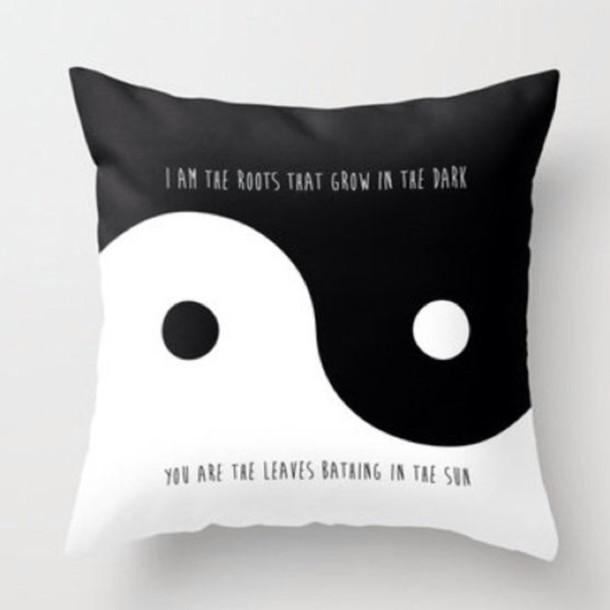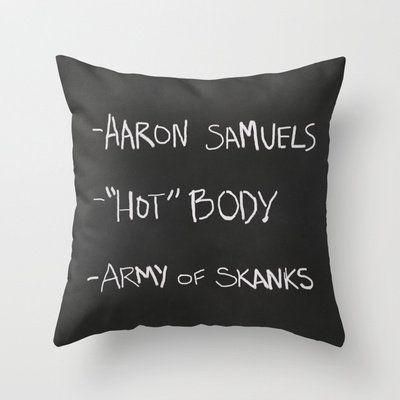The first image is the image on the left, the second image is the image on the right. Analyze the images presented: Is the assertion "IN at least one image there is a light gray pillow with at least five lines of white writing." valid? Answer yes or no. No. 